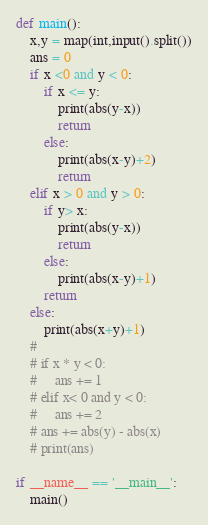Convert code to text. <code><loc_0><loc_0><loc_500><loc_500><_Python_>def main():
    x,y = map(int,input().split())
    ans = 0
    if x <0 and y < 0:
        if x <= y:
            print(abs(y-x))
            return
        else:
            print(abs(x-y)+2)
            return
    elif x > 0 and y > 0:
        if y> x:
            print(abs(y-x))
            return
        else:
            print(abs(x-y)+1)
        return
    else:
        print(abs(x+y)+1)
    #
    # if x * y < 0:
    #     ans += 1
    # elif x< 0 and y < 0:
    #     ans += 2
    # ans += abs(y) - abs(x)
    # print(ans)

if __name__ == '__main__':
    main()
</code> 